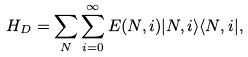<formula> <loc_0><loc_0><loc_500><loc_500>H _ { D } = \sum _ { N } \sum ^ { \infty } _ { i = 0 } E ( N , i ) | N , i \rangle \langle N , i | ,</formula> 